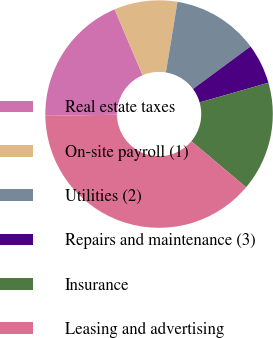Convert chart to OTSL. <chart><loc_0><loc_0><loc_500><loc_500><pie_chart><fcel>Real estate taxes<fcel>On-site payroll (1)<fcel>Utilities (2)<fcel>Repairs and maintenance (3)<fcel>Insurance<fcel>Leasing and advertising<nl><fcel>18.86%<fcel>8.98%<fcel>12.28%<fcel>5.69%<fcel>15.57%<fcel>38.62%<nl></chart> 